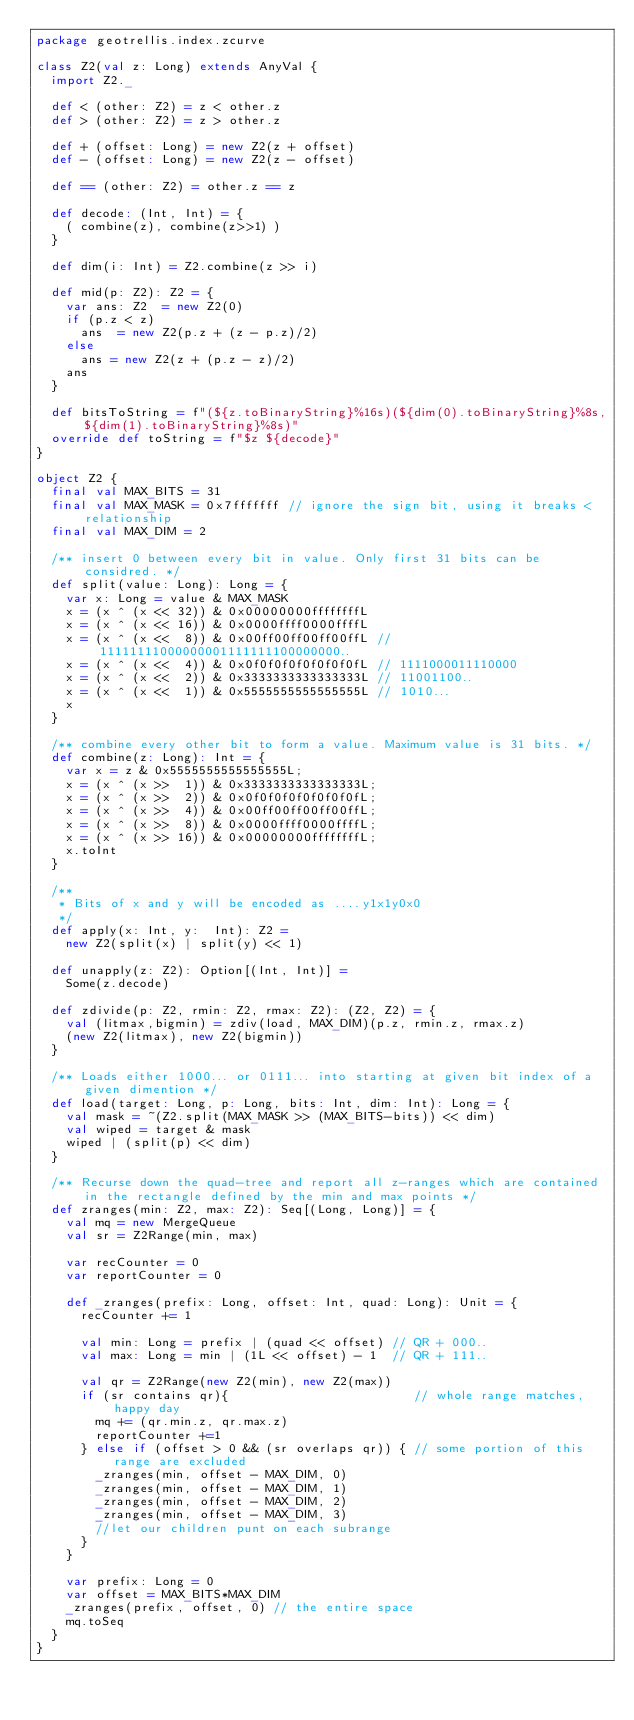Convert code to text. <code><loc_0><loc_0><loc_500><loc_500><_Scala_>package geotrellis.index.zcurve

class Z2(val z: Long) extends AnyVal {
  import Z2._

  def < (other: Z2) = z < other.z
  def > (other: Z2) = z > other.z

  def + (offset: Long) = new Z2(z + offset)
  def - (offset: Long) = new Z2(z - offset)

  def == (other: Z2) = other.z == z

  def decode: (Int, Int) = {    
    ( combine(z), combine(z>>1) )      
  }

  def dim(i: Int) = Z2.combine(z >> i)

  def mid(p: Z2): Z2 = {
    var ans: Z2  = new Z2(0)
    if (p.z < z)
      ans  = new Z2(p.z + (z - p.z)/2)
    else
      ans = new Z2(z + (p.z - z)/2)
    ans
  }

  def bitsToString = f"(${z.toBinaryString}%16s)(${dim(0).toBinaryString}%8s,${dim(1).toBinaryString}%8s)"
  override def toString = f"$z ${decode}"
}

object Z2 {  
  final val MAX_BITS = 31
  final val MAX_MASK = 0x7fffffff // ignore the sign bit, using it breaks < relationship
  final val MAX_DIM = 2

  /** insert 0 between every bit in value. Only first 31 bits can be considred. */
  def split(value: Long): Long = {
    var x: Long = value & MAX_MASK  
    x = (x ^ (x << 32)) & 0x00000000ffffffffL
    x = (x ^ (x << 16)) & 0x0000ffff0000ffffL
    x = (x ^ (x <<  8)) & 0x00ff00ff00ff00ffL // 11111111000000001111111100000000..
    x = (x ^ (x <<  4)) & 0x0f0f0f0f0f0f0f0fL // 1111000011110000
    x = (x ^ (x <<  2)) & 0x3333333333333333L // 11001100..
    x = (x ^ (x <<  1)) & 0x5555555555555555L // 1010...
    x
  }

  /** combine every other bit to form a value. Maximum value is 31 bits. */
  def combine(z: Long): Int = {
    var x = z & 0x5555555555555555L;
    x = (x ^ (x >>  1)) & 0x3333333333333333L;
    x = (x ^ (x >>  2)) & 0x0f0f0f0f0f0f0f0fL;
    x = (x ^ (x >>  4)) & 0x00ff00ff00ff00ffL;
    x = (x ^ (x >>  8)) & 0x0000ffff0000ffffL;
    x = (x ^ (x >> 16)) & 0x00000000ffffffffL;       
    x.toInt
  }

  /**
   * Bits of x and y will be encoded as ....y1x1y0x0
   */
  def apply(x: Int, y:  Int): Z2 = 
    new Z2(split(x) | split(y) << 1)  

  def unapply(z: Z2): Option[(Int, Int)] = 
    Some(z.decode)
  
  def zdivide(p: Z2, rmin: Z2, rmax: Z2): (Z2, Z2) = {
    val (litmax,bigmin) = zdiv(load, MAX_DIM)(p.z, rmin.z, rmax.z)
    (new Z2(litmax), new Z2(bigmin))
  }
  
  /** Loads either 1000... or 0111... into starting at given bit index of a given dimention */
  def load(target: Long, p: Long, bits: Int, dim: Int): Long = {    
    val mask = ~(Z2.split(MAX_MASK >> (MAX_BITS-bits)) << dim)
    val wiped = target & mask
    wiped | (split(p) << dim)
  }  

  /** Recurse down the quad-tree and report all z-ranges which are contained in the rectangle defined by the min and max points */
  def zranges(min: Z2, max: Z2): Seq[(Long, Long)] = {
    val mq = new MergeQueue
    val sr = Z2Range(min, max)

    var recCounter = 0
    var reportCounter = 0

    def _zranges(prefix: Long, offset: Int, quad: Long): Unit = {      
      recCounter += 1

      val min: Long = prefix | (quad << offset) // QR + 000..
      val max: Long = min | (1L << offset) - 1  // QR + 111..
      
      val qr = Z2Range(new Z2(min), new Z2(max))
      if (sr contains qr){                         // whole range matches, happy day
        mq += (qr.min.z, qr.max.z)
        reportCounter +=1
      } else if (offset > 0 && (sr overlaps qr)) { // some portion of this range are excluded
        _zranges(min, offset - MAX_DIM, 0)
        _zranges(min, offset - MAX_DIM, 1)
        _zranges(min, offset - MAX_DIM, 2)
        _zranges(min, offset - MAX_DIM, 3)        
        //let our children punt on each subrange
      }
    }

    var prefix: Long = 0
    var offset = MAX_BITS*MAX_DIM                
    _zranges(prefix, offset, 0) // the entire space
    mq.toSeq
  }
}
</code> 